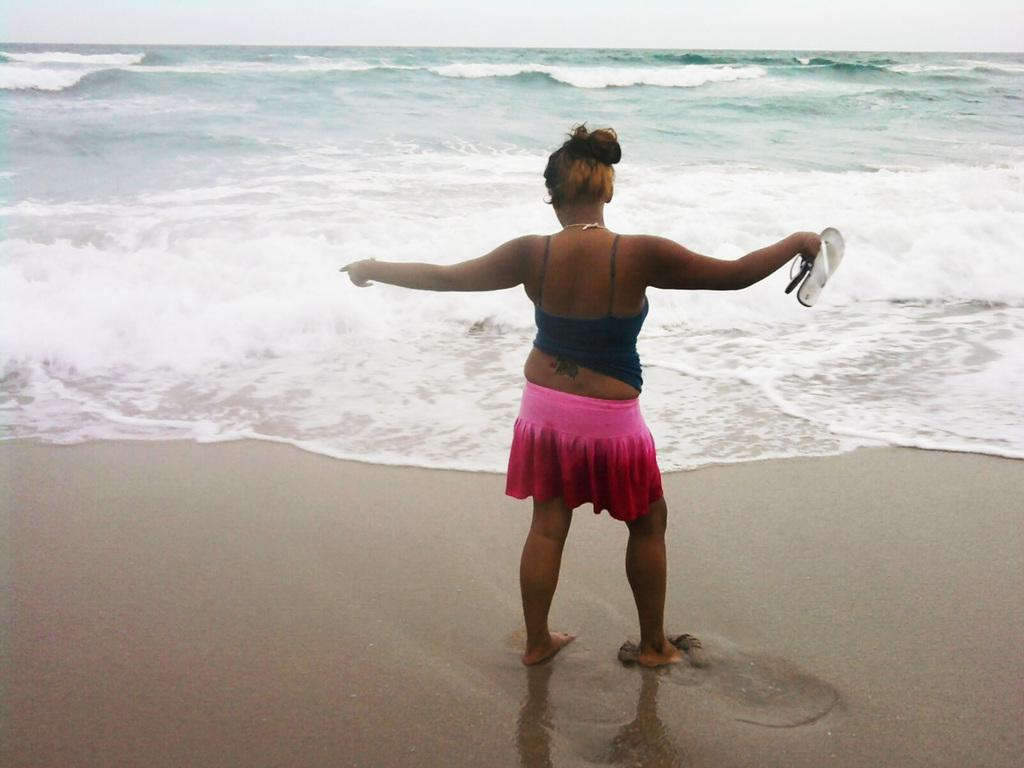Who is present in the image? There is a woman in the image. What is the woman holding in the image? The woman is holding footwear. Where is the woman located in the image? The woman is standing on the sea shore. What can be seen in the background of the image? There is water and the sky visible in the background of the image. What type of circle can be seen in the image? There is no circle present in the image. What is the cause of death in the image? There is no death or any indication of death in the image. 